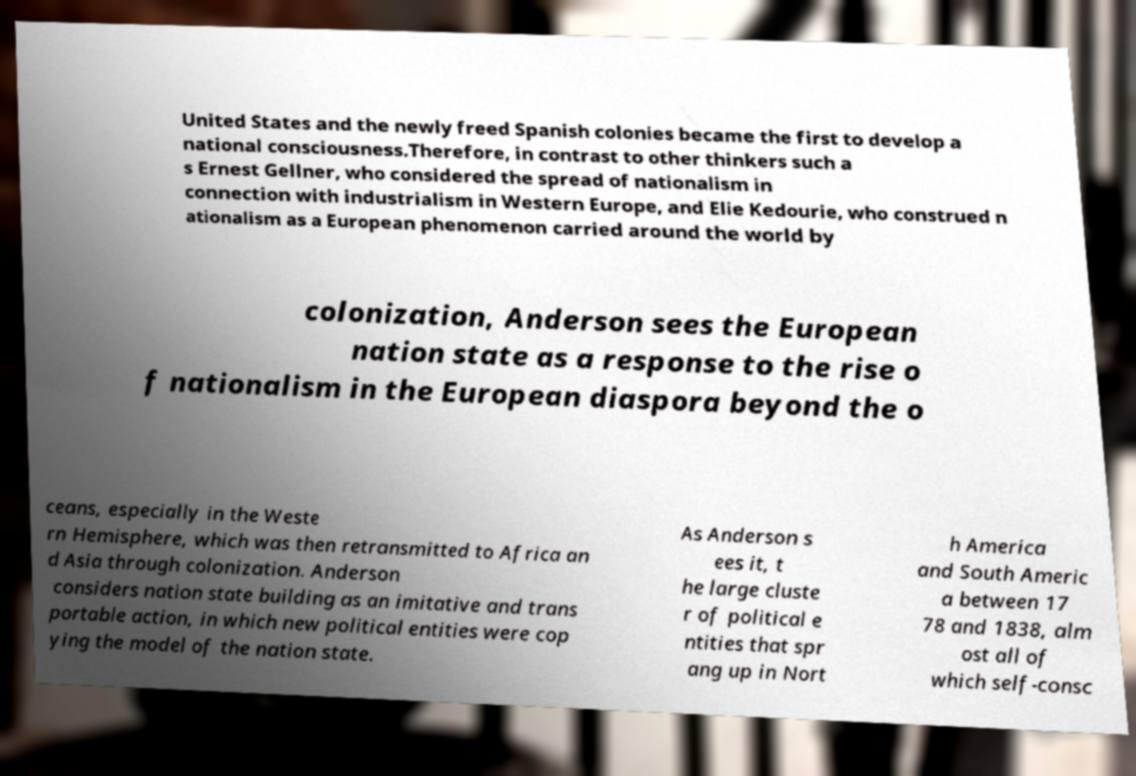What messages or text are displayed in this image? I need them in a readable, typed format. United States and the newly freed Spanish colonies became the first to develop a national consciousness.Therefore, in contrast to other thinkers such a s Ernest Gellner, who considered the spread of nationalism in connection with industrialism in Western Europe, and Elie Kedourie, who construed n ationalism as a European phenomenon carried around the world by colonization, Anderson sees the European nation state as a response to the rise o f nationalism in the European diaspora beyond the o ceans, especially in the Weste rn Hemisphere, which was then retransmitted to Africa an d Asia through colonization. Anderson considers nation state building as an imitative and trans portable action, in which new political entities were cop ying the model of the nation state. As Anderson s ees it, t he large cluste r of political e ntities that spr ang up in Nort h America and South Americ a between 17 78 and 1838, alm ost all of which self-consc 